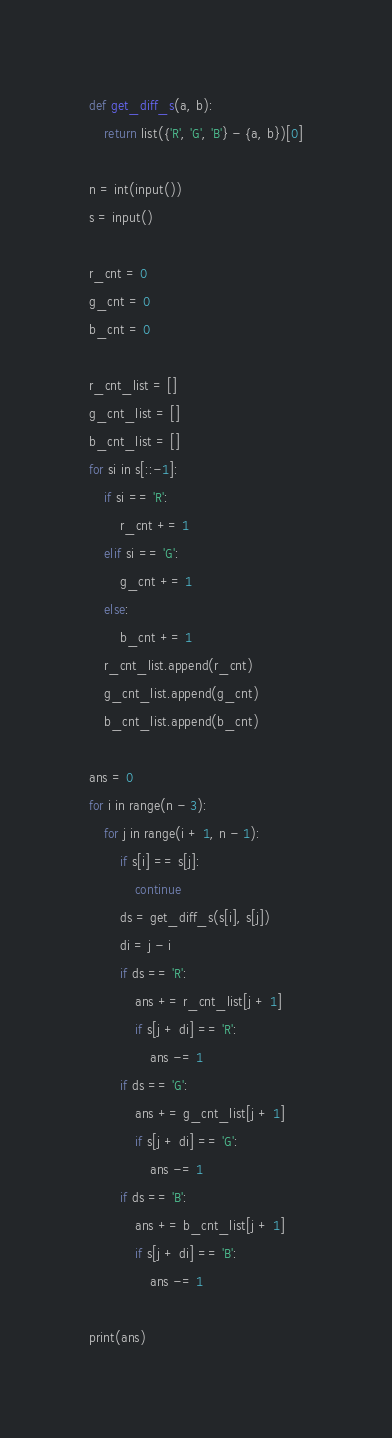<code> <loc_0><loc_0><loc_500><loc_500><_Python_>def get_diff_s(a, b):
    return list({'R', 'G', 'B'} - {a, b})[0]

n = int(input())
s = input()

r_cnt = 0
g_cnt = 0
b_cnt = 0

r_cnt_list = []
g_cnt_list = []
b_cnt_list = []
for si in s[::-1]:
    if si == 'R':
        r_cnt += 1
    elif si == 'G':
        g_cnt += 1
    else:
        b_cnt += 1
    r_cnt_list.append(r_cnt)
    g_cnt_list.append(g_cnt)
    b_cnt_list.append(b_cnt)

ans = 0
for i in range(n - 3):
    for j in range(i + 1, n - 1):
        if s[i] == s[j]:
            continue
        ds = get_diff_s(s[i], s[j])
        di = j - i
        if ds == 'R':
            ans += r_cnt_list[j + 1]
            if s[j + di] == 'R':
                ans -= 1
        if ds == 'G':
            ans += g_cnt_list[j + 1]
            if s[j + di] == 'G':
                ans -= 1
        if ds == 'B':
            ans += b_cnt_list[j + 1]
            if s[j + di] == 'B':
                ans -= 1

print(ans)</code> 